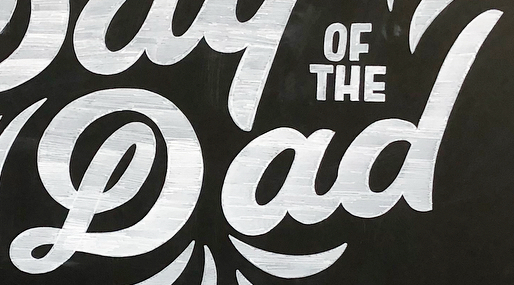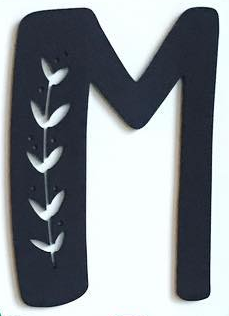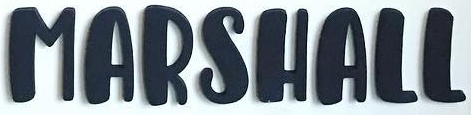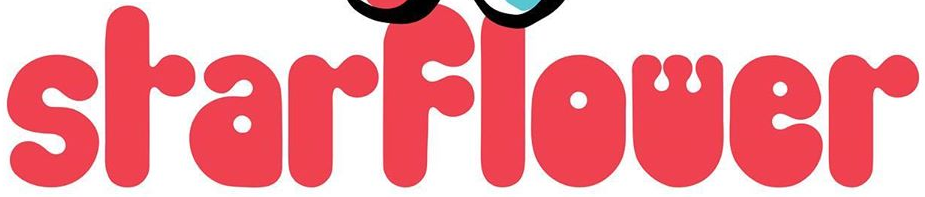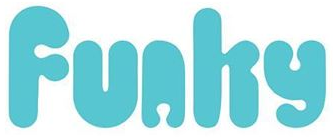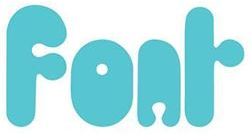Identify the words shown in these images in order, separated by a semicolon. Dad; M; MARSHALL; SrarFlower; Funhy; Fonr 